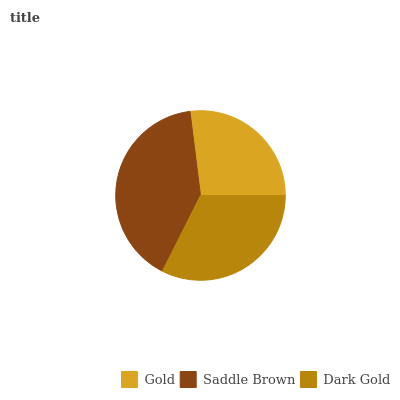Is Gold the minimum?
Answer yes or no. Yes. Is Saddle Brown the maximum?
Answer yes or no. Yes. Is Dark Gold the minimum?
Answer yes or no. No. Is Dark Gold the maximum?
Answer yes or no. No. Is Saddle Brown greater than Dark Gold?
Answer yes or no. Yes. Is Dark Gold less than Saddle Brown?
Answer yes or no. Yes. Is Dark Gold greater than Saddle Brown?
Answer yes or no. No. Is Saddle Brown less than Dark Gold?
Answer yes or no. No. Is Dark Gold the high median?
Answer yes or no. Yes. Is Dark Gold the low median?
Answer yes or no. Yes. Is Gold the high median?
Answer yes or no. No. Is Saddle Brown the low median?
Answer yes or no. No. 